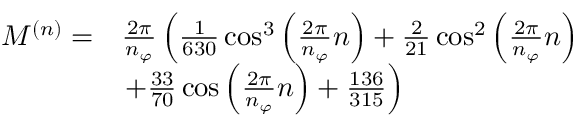<formula> <loc_0><loc_0><loc_500><loc_500>\begin{array} { r l } { M ^ { ( n ) } = } & { \frac { 2 \pi } { n _ { \varphi } } \left ( \frac { 1 } { 6 3 0 } \cos ^ { 3 } \left ( \frac { 2 \pi } { n _ { \varphi } } n \right ) + \frac { 2 } { 2 1 } \cos ^ { 2 } \left ( \frac { 2 \pi } { n _ { \varphi } } n \right ) } \\ & { + \frac { 3 3 } { 7 0 } \cos \left ( \frac { 2 \pi } { n _ { \varphi } } n \right ) + \frac { 1 3 6 } { 3 1 5 } \right ) } \end{array}</formula> 